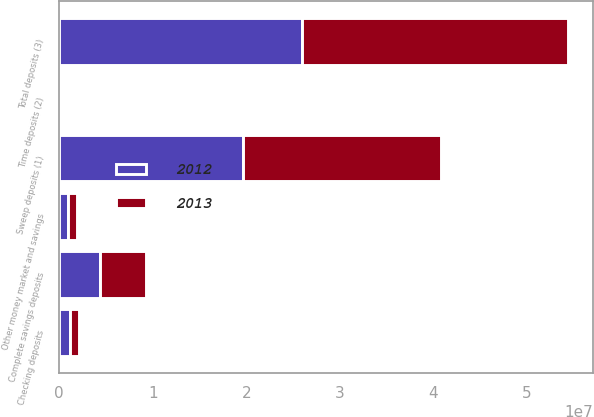<chart> <loc_0><loc_0><loc_500><loc_500><stacked_bar_chart><ecel><fcel>Sweep deposits (1)<fcel>Complete savings deposits<fcel>Checking deposits<fcel>Other money market and savings<fcel>Time deposits (2)<fcel>Total deposits (3)<nl><fcel>2012<fcel>1.95921e+07<fcel>4.3029e+06<fcel>1.09802e+06<fcel>914043<fcel>63748<fcel>2.59708e+07<nl><fcel>2013<fcel>2.12536e+07<fcel>4.98162e+06<fcel>1.05542e+06<fcel>995188<fcel>106716<fcel>2.83926e+07<nl></chart> 